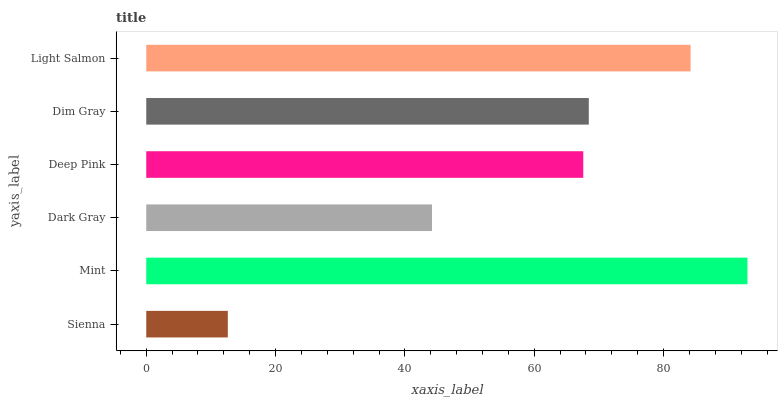Is Sienna the minimum?
Answer yes or no. Yes. Is Mint the maximum?
Answer yes or no. Yes. Is Dark Gray the minimum?
Answer yes or no. No. Is Dark Gray the maximum?
Answer yes or no. No. Is Mint greater than Dark Gray?
Answer yes or no. Yes. Is Dark Gray less than Mint?
Answer yes or no. Yes. Is Dark Gray greater than Mint?
Answer yes or no. No. Is Mint less than Dark Gray?
Answer yes or no. No. Is Dim Gray the high median?
Answer yes or no. Yes. Is Deep Pink the low median?
Answer yes or no. Yes. Is Dark Gray the high median?
Answer yes or no. No. Is Light Salmon the low median?
Answer yes or no. No. 